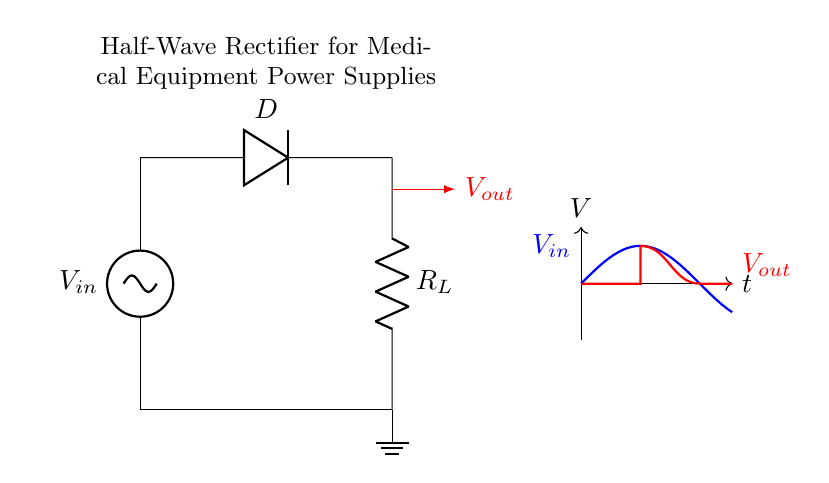What type of rectifier is shown in the circuit? The circuit diagram displays a half-wave rectifier, which only allows half of the AC input signal to pass through while blocking the other half. This is evident from the presence of a single diode used in the circuit.
Answer: half-wave rectifier What is the function of the diode in this circuit? The diode in the circuit allows current to flow in one direction only, effectively converting AC voltage to a pulsating DC voltage by blocking half of the input waveform. This function is crucial for ensuring that the medical equipment receives a usable power supply.
Answer: converts AC to DC What is the role of the load resistor? The load resistor provides a pathway for the current to flow after the rectification process, allowing the converted DC voltage to power the connected medical device. It determines the load characteristics and is essential for the functionality of the rectifier circuit.
Answer: provides load What happens to the output voltage during negative cycles of the input voltage? During the negative cycles of the input AC voltage, the diode blocks the current, resulting in zero output voltage. This is characteristic of a half-wave rectifier, where only one polarity of the voltage is utilized for output.
Answer: zero How does the output voltage waveform compare to the input voltage waveform? The output waveform comprises only the positive half-cycles of the input waveform, resulting in a series of positive pulses, while the negative half-cycles are clipped off. This can be observed in the waveform section of the diagram.
Answer: positive pulses 